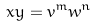Convert formula to latex. <formula><loc_0><loc_0><loc_500><loc_500>x y = v ^ { m } w ^ { n }</formula> 